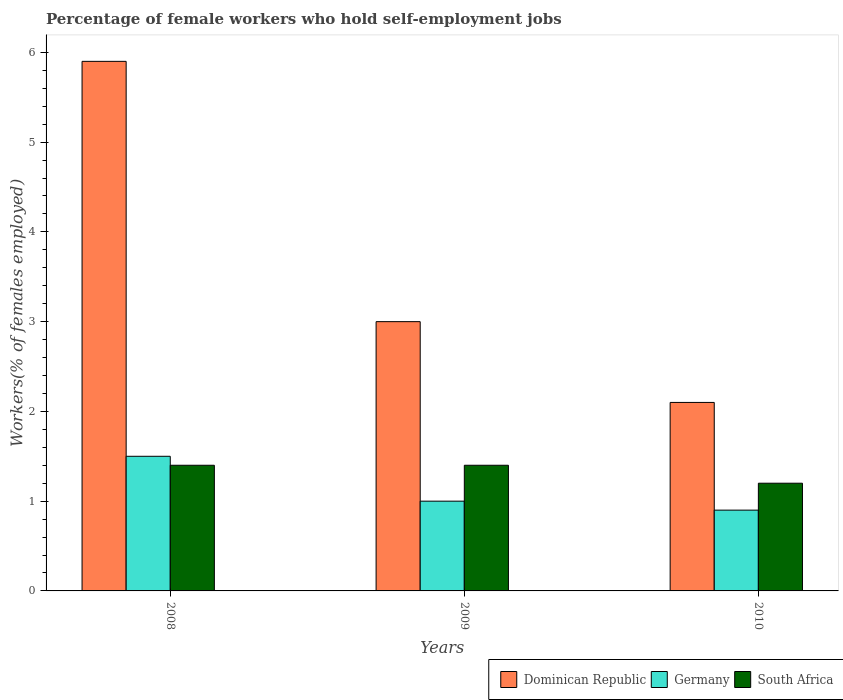How many different coloured bars are there?
Offer a very short reply. 3. Are the number of bars on each tick of the X-axis equal?
Your answer should be very brief. Yes. What is the label of the 2nd group of bars from the left?
Your response must be concise. 2009. In how many cases, is the number of bars for a given year not equal to the number of legend labels?
Keep it short and to the point. 0. What is the percentage of self-employed female workers in Dominican Republic in 2008?
Offer a terse response. 5.9. Across all years, what is the maximum percentage of self-employed female workers in Dominican Republic?
Give a very brief answer. 5.9. Across all years, what is the minimum percentage of self-employed female workers in Dominican Republic?
Ensure brevity in your answer.  2.1. In which year was the percentage of self-employed female workers in Germany minimum?
Your answer should be compact. 2010. What is the total percentage of self-employed female workers in Dominican Republic in the graph?
Offer a very short reply. 11. What is the difference between the percentage of self-employed female workers in Germany in 2009 and that in 2010?
Your answer should be very brief. 0.1. What is the difference between the percentage of self-employed female workers in Dominican Republic in 2008 and the percentage of self-employed female workers in Germany in 2009?
Offer a terse response. 4.9. What is the average percentage of self-employed female workers in South Africa per year?
Ensure brevity in your answer.  1.33. In how many years, is the percentage of self-employed female workers in Dominican Republic greater than 3.6 %?
Provide a short and direct response. 1. What is the ratio of the percentage of self-employed female workers in Dominican Republic in 2009 to that in 2010?
Your response must be concise. 1.43. Is the difference between the percentage of self-employed female workers in Dominican Republic in 2008 and 2009 greater than the difference between the percentage of self-employed female workers in Germany in 2008 and 2009?
Offer a very short reply. Yes. What is the difference between the highest and the lowest percentage of self-employed female workers in Dominican Republic?
Offer a very short reply. 3.8. In how many years, is the percentage of self-employed female workers in South Africa greater than the average percentage of self-employed female workers in South Africa taken over all years?
Your answer should be compact. 2. Is the sum of the percentage of self-employed female workers in South Africa in 2009 and 2010 greater than the maximum percentage of self-employed female workers in Germany across all years?
Give a very brief answer. Yes. What does the 1st bar from the left in 2010 represents?
Your answer should be compact. Dominican Republic. What does the 3rd bar from the right in 2010 represents?
Your answer should be compact. Dominican Republic. Are the values on the major ticks of Y-axis written in scientific E-notation?
Your answer should be very brief. No. Does the graph contain any zero values?
Offer a very short reply. No. Does the graph contain grids?
Provide a short and direct response. No. How are the legend labels stacked?
Ensure brevity in your answer.  Horizontal. What is the title of the graph?
Offer a terse response. Percentage of female workers who hold self-employment jobs. Does "Middle East & North Africa (all income levels)" appear as one of the legend labels in the graph?
Your answer should be compact. No. What is the label or title of the Y-axis?
Your answer should be very brief. Workers(% of females employed). What is the Workers(% of females employed) of Dominican Republic in 2008?
Your answer should be very brief. 5.9. What is the Workers(% of females employed) of South Africa in 2008?
Offer a terse response. 1.4. What is the Workers(% of females employed) of Dominican Republic in 2009?
Provide a short and direct response. 3. What is the Workers(% of females employed) of South Africa in 2009?
Ensure brevity in your answer.  1.4. What is the Workers(% of females employed) of Dominican Republic in 2010?
Keep it short and to the point. 2.1. What is the Workers(% of females employed) in Germany in 2010?
Provide a succinct answer. 0.9. What is the Workers(% of females employed) in South Africa in 2010?
Offer a terse response. 1.2. Across all years, what is the maximum Workers(% of females employed) of Dominican Republic?
Offer a terse response. 5.9. Across all years, what is the maximum Workers(% of females employed) in South Africa?
Give a very brief answer. 1.4. Across all years, what is the minimum Workers(% of females employed) of Dominican Republic?
Provide a short and direct response. 2.1. Across all years, what is the minimum Workers(% of females employed) in Germany?
Keep it short and to the point. 0.9. Across all years, what is the minimum Workers(% of females employed) in South Africa?
Make the answer very short. 1.2. What is the total Workers(% of females employed) of Dominican Republic in the graph?
Make the answer very short. 11. What is the total Workers(% of females employed) of Germany in the graph?
Make the answer very short. 3.4. What is the difference between the Workers(% of females employed) in Dominican Republic in 2008 and that in 2009?
Provide a short and direct response. 2.9. What is the difference between the Workers(% of females employed) in Germany in 2008 and that in 2009?
Offer a very short reply. 0.5. What is the difference between the Workers(% of females employed) in Dominican Republic in 2008 and that in 2010?
Make the answer very short. 3.8. What is the difference between the Workers(% of females employed) of Germany in 2008 and that in 2010?
Offer a very short reply. 0.6. What is the difference between the Workers(% of females employed) of South Africa in 2009 and that in 2010?
Your response must be concise. 0.2. What is the difference between the Workers(% of females employed) of Dominican Republic in 2008 and the Workers(% of females employed) of South Africa in 2009?
Your answer should be very brief. 4.5. What is the difference between the Workers(% of females employed) of Dominican Republic in 2008 and the Workers(% of females employed) of Germany in 2010?
Provide a succinct answer. 5. What is the difference between the Workers(% of females employed) in Dominican Republic in 2008 and the Workers(% of females employed) in South Africa in 2010?
Offer a terse response. 4.7. What is the difference between the Workers(% of females employed) in Dominican Republic in 2009 and the Workers(% of females employed) in Germany in 2010?
Make the answer very short. 2.1. What is the difference between the Workers(% of females employed) of Dominican Republic in 2009 and the Workers(% of females employed) of South Africa in 2010?
Provide a succinct answer. 1.8. What is the average Workers(% of females employed) of Dominican Republic per year?
Make the answer very short. 3.67. What is the average Workers(% of females employed) in Germany per year?
Give a very brief answer. 1.13. What is the average Workers(% of females employed) of South Africa per year?
Provide a short and direct response. 1.33. In the year 2008, what is the difference between the Workers(% of females employed) in Dominican Republic and Workers(% of females employed) in South Africa?
Make the answer very short. 4.5. In the year 2009, what is the difference between the Workers(% of females employed) in Dominican Republic and Workers(% of females employed) in Germany?
Offer a terse response. 2. In the year 2010, what is the difference between the Workers(% of females employed) of Dominican Republic and Workers(% of females employed) of Germany?
Your answer should be compact. 1.2. What is the ratio of the Workers(% of females employed) of Dominican Republic in 2008 to that in 2009?
Provide a short and direct response. 1.97. What is the ratio of the Workers(% of females employed) of Germany in 2008 to that in 2009?
Ensure brevity in your answer.  1.5. What is the ratio of the Workers(% of females employed) of South Africa in 2008 to that in 2009?
Your answer should be compact. 1. What is the ratio of the Workers(% of females employed) in Dominican Republic in 2008 to that in 2010?
Make the answer very short. 2.81. What is the ratio of the Workers(% of females employed) of South Africa in 2008 to that in 2010?
Give a very brief answer. 1.17. What is the ratio of the Workers(% of females employed) in Dominican Republic in 2009 to that in 2010?
Provide a short and direct response. 1.43. What is the ratio of the Workers(% of females employed) in South Africa in 2009 to that in 2010?
Your answer should be very brief. 1.17. What is the difference between the highest and the lowest Workers(% of females employed) in Germany?
Provide a short and direct response. 0.6. 